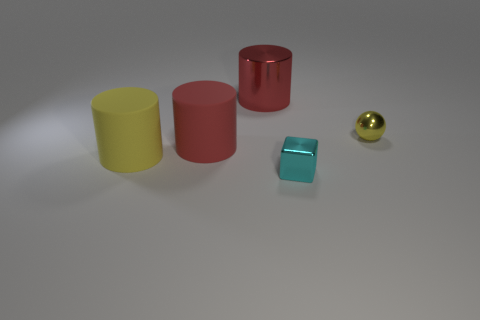Add 2 tiny yellow metallic balls. How many objects exist? 7 Subtract all cylinders. How many objects are left? 2 Subtract 1 cyan cubes. How many objects are left? 4 Subtract all big blue rubber objects. Subtract all small yellow shiny spheres. How many objects are left? 4 Add 1 red rubber objects. How many red rubber objects are left? 2 Add 5 large metal cylinders. How many large metal cylinders exist? 6 